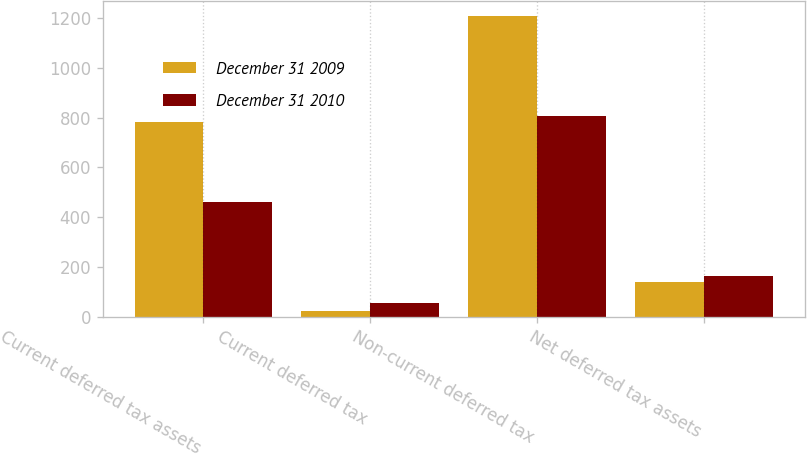Convert chart. <chart><loc_0><loc_0><loc_500><loc_500><stacked_bar_chart><ecel><fcel>Current deferred tax assets<fcel>Current deferred tax<fcel>Non-current deferred tax<fcel>Net deferred tax assets<nl><fcel>December 31 2009<fcel>782<fcel>23<fcel>1207<fcel>140<nl><fcel>December 31 2010<fcel>462<fcel>57<fcel>807<fcel>162<nl></chart> 